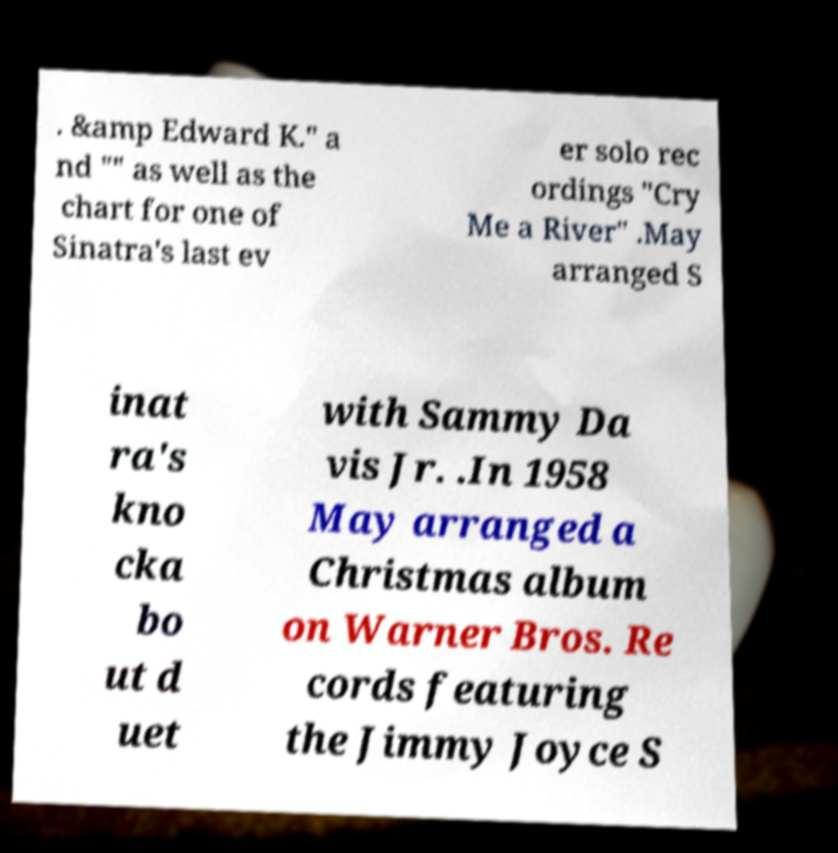I need the written content from this picture converted into text. Can you do that? . &amp Edward K." a nd "" as well as the chart for one of Sinatra's last ev er solo rec ordings "Cry Me a River" .May arranged S inat ra's kno cka bo ut d uet with Sammy Da vis Jr. .In 1958 May arranged a Christmas album on Warner Bros. Re cords featuring the Jimmy Joyce S 